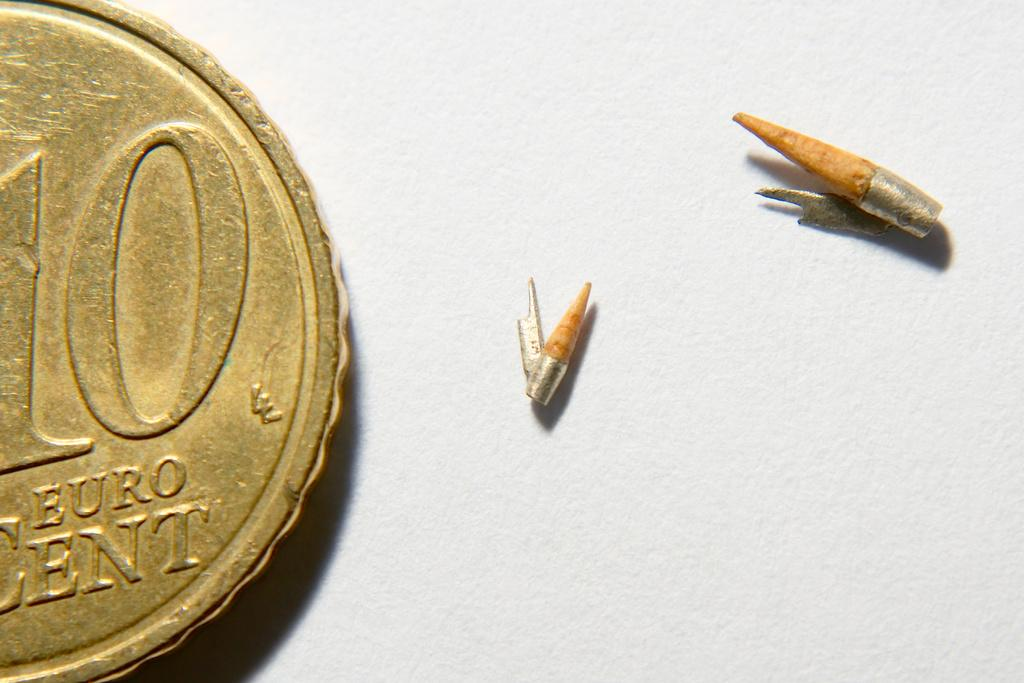<image>
Offer a succinct explanation of the picture presented. Two small, pointy objects sit near a 10 cent euro. 